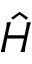<formula> <loc_0><loc_0><loc_500><loc_500>\hat { H }</formula> 